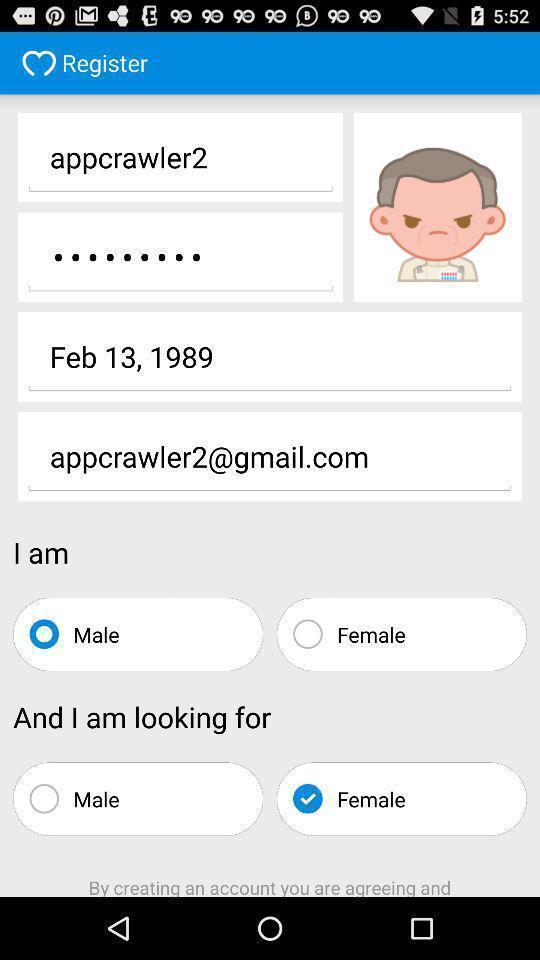Explain what's happening in this screen capture. Sign up page. 